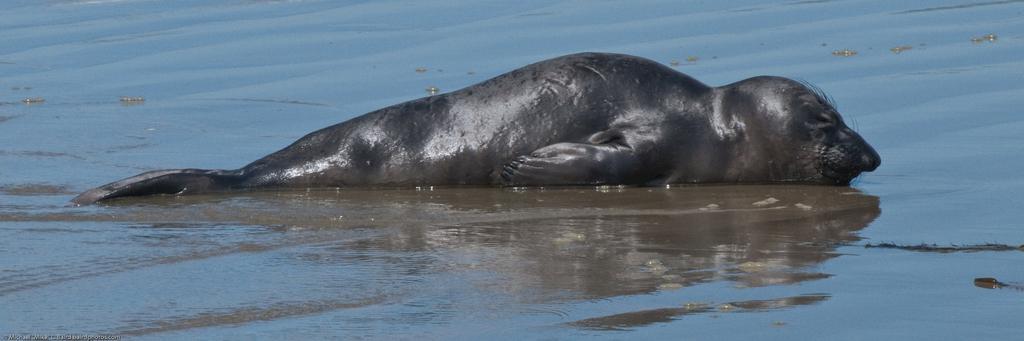Can you describe this image briefly? In this image I can see the ground, some water on the ground and an aquatic animal which is black in color on the ground. 